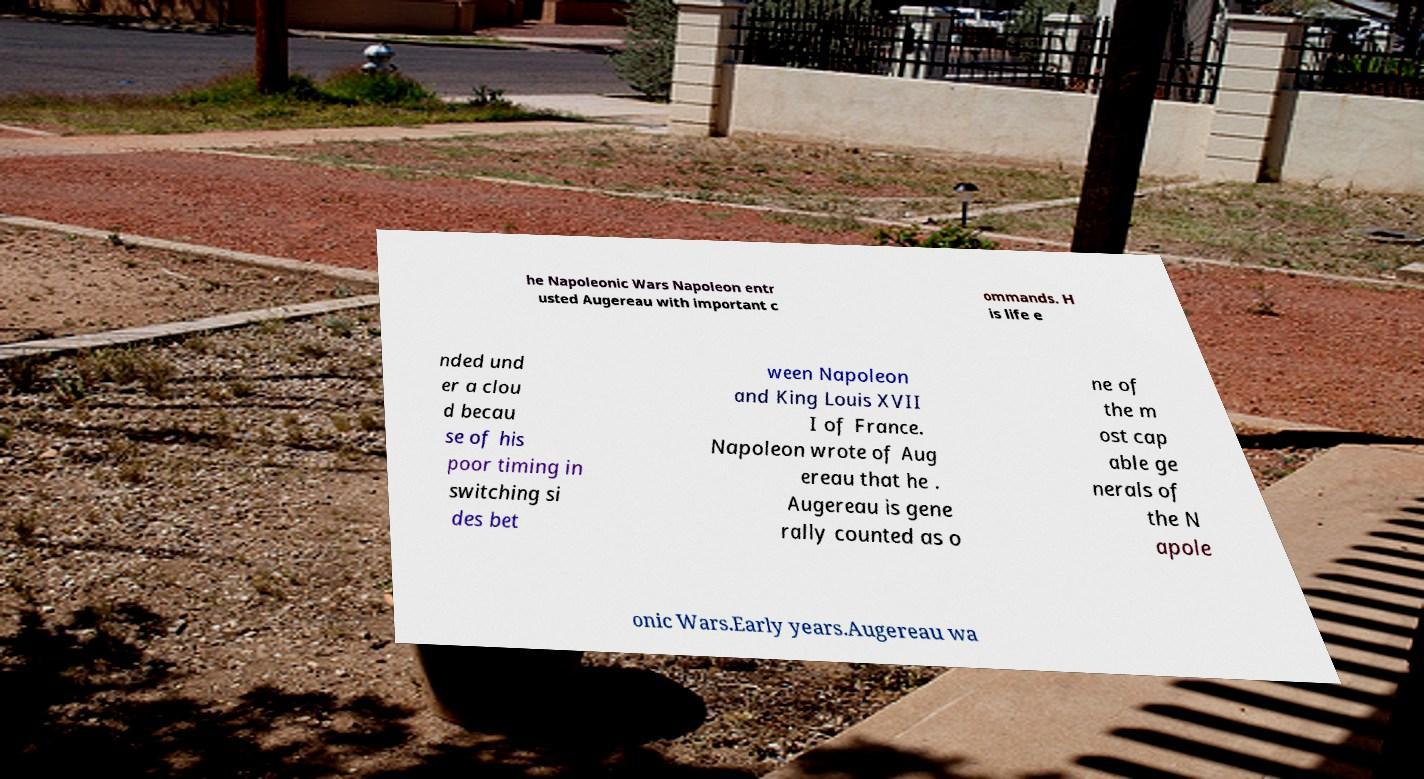There's text embedded in this image that I need extracted. Can you transcribe it verbatim? he Napoleonic Wars Napoleon entr usted Augereau with important c ommands. H is life e nded und er a clou d becau se of his poor timing in switching si des bet ween Napoleon and King Louis XVII I of France. Napoleon wrote of Aug ereau that he . Augereau is gene rally counted as o ne of the m ost cap able ge nerals of the N apole onic Wars.Early years.Augereau wa 